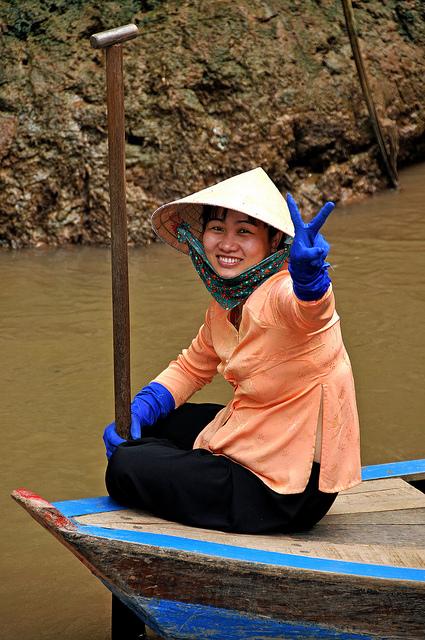What sign is the woman making?
Concise answer only. Peace. What region does this woman's fashion suggest?
Concise answer only. Asia. Is the water dirty?
Answer briefly. Yes. 